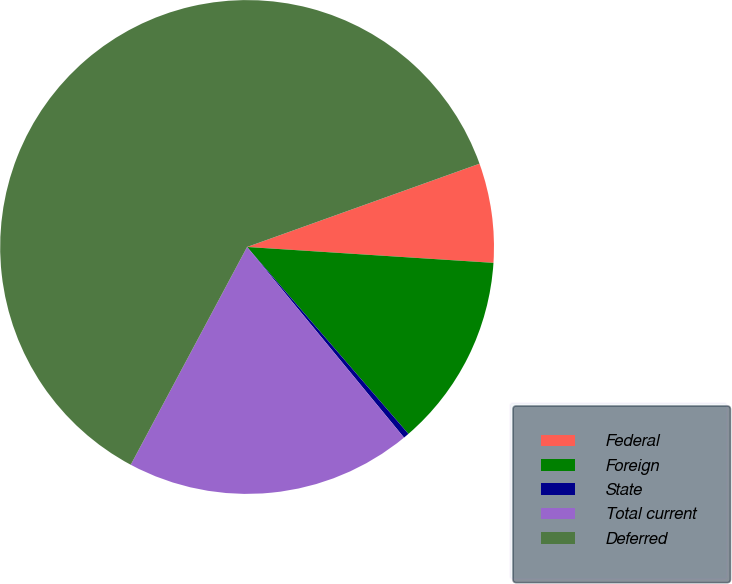Convert chart to OTSL. <chart><loc_0><loc_0><loc_500><loc_500><pie_chart><fcel>Federal<fcel>Foreign<fcel>State<fcel>Total current<fcel>Deferred<nl><fcel>6.5%<fcel>12.64%<fcel>0.37%<fcel>18.77%<fcel>61.71%<nl></chart> 